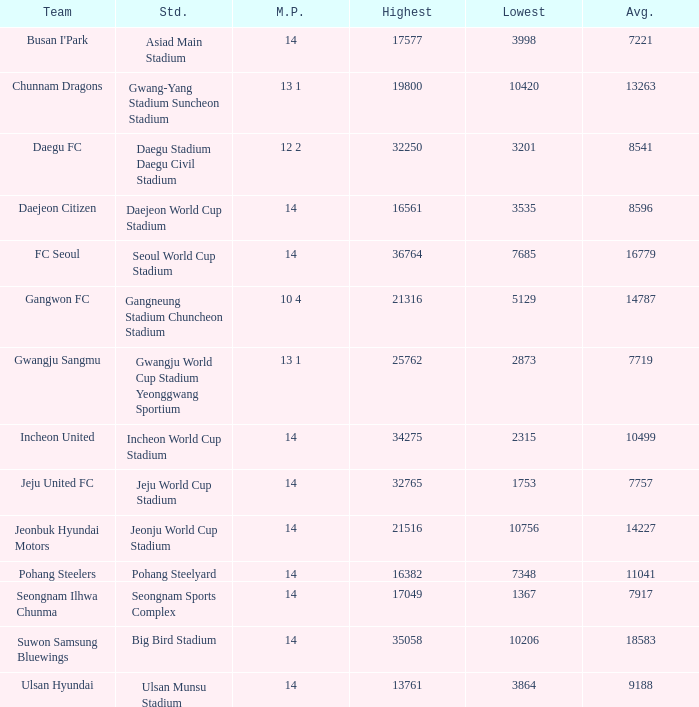Which team has 7757 as the average? Jeju United FC. 